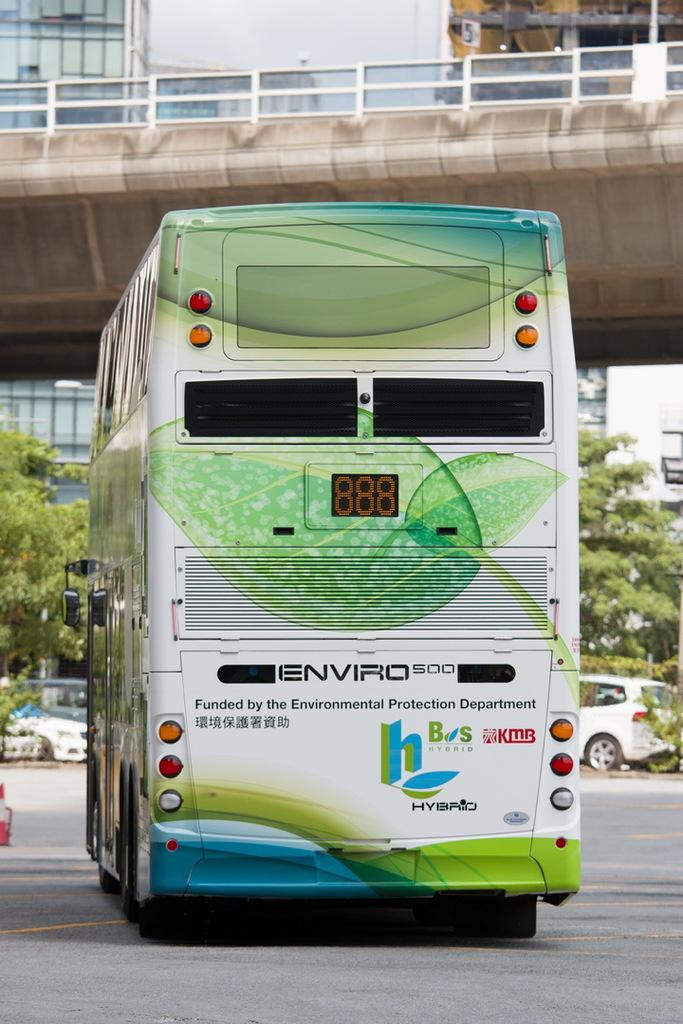What types of vehicles can be seen in the image? There are vehicles in the image, but the specific types are not mentioned. What is the primary surface on which the vehicles are traveling? There is a road in the image, which is likely the surface on which the vehicles are traveling. What structure is present over a body of water in the image? There is a bridge in the image that spans over a body of water. What type of vegetation is present in the image? There are trees in the image. What type of man-made structures are visible in the image? There are buildings in the image. What type of ear is visible on the passenger in the image? There is no passenger present in the image, and therefore no ear can be observed. What type of beast is crossing the bridge in the image? There is no beast present in the image; the bridge is likely being used by vehicles. 